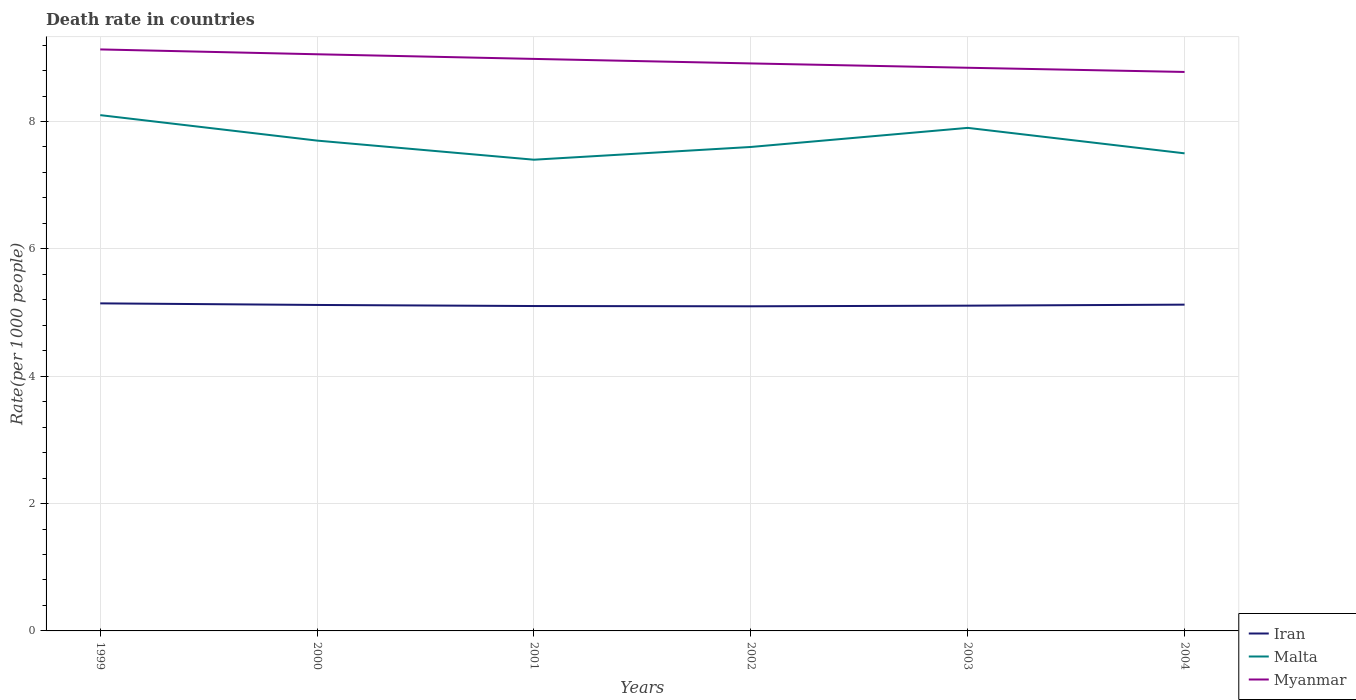How many different coloured lines are there?
Your answer should be compact. 3. Is the number of lines equal to the number of legend labels?
Keep it short and to the point. Yes. Across all years, what is the maximum death rate in Iran?
Your answer should be very brief. 5.1. What is the total death rate in Malta in the graph?
Your answer should be very brief. 0.1. What is the difference between the highest and the second highest death rate in Iran?
Your answer should be compact. 0.05. What is the difference between the highest and the lowest death rate in Iran?
Provide a succinct answer. 3. Is the death rate in Malta strictly greater than the death rate in Myanmar over the years?
Give a very brief answer. Yes. Are the values on the major ticks of Y-axis written in scientific E-notation?
Ensure brevity in your answer.  No. Does the graph contain any zero values?
Make the answer very short. No. What is the title of the graph?
Give a very brief answer. Death rate in countries. Does "Nigeria" appear as one of the legend labels in the graph?
Give a very brief answer. No. What is the label or title of the Y-axis?
Offer a very short reply. Rate(per 1000 people). What is the Rate(per 1000 people) of Iran in 1999?
Your answer should be very brief. 5.14. What is the Rate(per 1000 people) of Malta in 1999?
Provide a short and direct response. 8.1. What is the Rate(per 1000 people) in Myanmar in 1999?
Keep it short and to the point. 9.13. What is the Rate(per 1000 people) of Iran in 2000?
Your answer should be compact. 5.12. What is the Rate(per 1000 people) of Myanmar in 2000?
Ensure brevity in your answer.  9.06. What is the Rate(per 1000 people) in Iran in 2001?
Make the answer very short. 5.1. What is the Rate(per 1000 people) of Myanmar in 2001?
Give a very brief answer. 8.98. What is the Rate(per 1000 people) in Iran in 2002?
Your answer should be very brief. 5.1. What is the Rate(per 1000 people) in Myanmar in 2002?
Provide a succinct answer. 8.91. What is the Rate(per 1000 people) in Iran in 2003?
Your answer should be compact. 5.11. What is the Rate(per 1000 people) of Malta in 2003?
Offer a very short reply. 7.9. What is the Rate(per 1000 people) of Myanmar in 2003?
Your answer should be compact. 8.84. What is the Rate(per 1000 people) in Iran in 2004?
Your response must be concise. 5.12. What is the Rate(per 1000 people) in Malta in 2004?
Your answer should be compact. 7.5. What is the Rate(per 1000 people) in Myanmar in 2004?
Offer a terse response. 8.78. Across all years, what is the maximum Rate(per 1000 people) of Iran?
Offer a terse response. 5.14. Across all years, what is the maximum Rate(per 1000 people) of Malta?
Offer a terse response. 8.1. Across all years, what is the maximum Rate(per 1000 people) of Myanmar?
Ensure brevity in your answer.  9.13. Across all years, what is the minimum Rate(per 1000 people) of Iran?
Keep it short and to the point. 5.1. Across all years, what is the minimum Rate(per 1000 people) in Myanmar?
Keep it short and to the point. 8.78. What is the total Rate(per 1000 people) in Iran in the graph?
Give a very brief answer. 30.7. What is the total Rate(per 1000 people) in Malta in the graph?
Ensure brevity in your answer.  46.2. What is the total Rate(per 1000 people) of Myanmar in the graph?
Provide a succinct answer. 53.7. What is the difference between the Rate(per 1000 people) of Iran in 1999 and that in 2000?
Provide a short and direct response. 0.03. What is the difference between the Rate(per 1000 people) of Malta in 1999 and that in 2000?
Offer a terse response. 0.4. What is the difference between the Rate(per 1000 people) in Myanmar in 1999 and that in 2000?
Provide a succinct answer. 0.08. What is the difference between the Rate(per 1000 people) of Iran in 1999 and that in 2001?
Offer a terse response. 0.04. What is the difference between the Rate(per 1000 people) in Myanmar in 1999 and that in 2001?
Make the answer very short. 0.15. What is the difference between the Rate(per 1000 people) in Iran in 1999 and that in 2002?
Your answer should be very brief. 0.05. What is the difference between the Rate(per 1000 people) in Myanmar in 1999 and that in 2002?
Your answer should be compact. 0.22. What is the difference between the Rate(per 1000 people) in Iran in 1999 and that in 2003?
Offer a very short reply. 0.04. What is the difference between the Rate(per 1000 people) in Myanmar in 1999 and that in 2003?
Offer a terse response. 0.29. What is the difference between the Rate(per 1000 people) of Malta in 1999 and that in 2004?
Make the answer very short. 0.6. What is the difference between the Rate(per 1000 people) in Myanmar in 1999 and that in 2004?
Provide a short and direct response. 0.35. What is the difference between the Rate(per 1000 people) of Iran in 2000 and that in 2001?
Your answer should be compact. 0.02. What is the difference between the Rate(per 1000 people) of Myanmar in 2000 and that in 2001?
Offer a very short reply. 0.07. What is the difference between the Rate(per 1000 people) of Iran in 2000 and that in 2002?
Offer a terse response. 0.02. What is the difference between the Rate(per 1000 people) in Myanmar in 2000 and that in 2002?
Your answer should be compact. 0.14. What is the difference between the Rate(per 1000 people) of Iran in 2000 and that in 2003?
Make the answer very short. 0.01. What is the difference between the Rate(per 1000 people) in Myanmar in 2000 and that in 2003?
Offer a terse response. 0.21. What is the difference between the Rate(per 1000 people) in Iran in 2000 and that in 2004?
Offer a very short reply. -0.01. What is the difference between the Rate(per 1000 people) in Myanmar in 2000 and that in 2004?
Provide a succinct answer. 0.28. What is the difference between the Rate(per 1000 people) in Iran in 2001 and that in 2002?
Ensure brevity in your answer.  0. What is the difference between the Rate(per 1000 people) in Malta in 2001 and that in 2002?
Make the answer very short. -0.2. What is the difference between the Rate(per 1000 people) in Myanmar in 2001 and that in 2002?
Offer a terse response. 0.07. What is the difference between the Rate(per 1000 people) of Iran in 2001 and that in 2003?
Your answer should be compact. -0.01. What is the difference between the Rate(per 1000 people) in Myanmar in 2001 and that in 2003?
Your answer should be very brief. 0.14. What is the difference between the Rate(per 1000 people) in Iran in 2001 and that in 2004?
Offer a very short reply. -0.02. What is the difference between the Rate(per 1000 people) of Myanmar in 2001 and that in 2004?
Ensure brevity in your answer.  0.2. What is the difference between the Rate(per 1000 people) in Iran in 2002 and that in 2003?
Offer a terse response. -0.01. What is the difference between the Rate(per 1000 people) of Malta in 2002 and that in 2003?
Offer a very short reply. -0.3. What is the difference between the Rate(per 1000 people) in Myanmar in 2002 and that in 2003?
Offer a very short reply. 0.07. What is the difference between the Rate(per 1000 people) in Iran in 2002 and that in 2004?
Provide a succinct answer. -0.03. What is the difference between the Rate(per 1000 people) in Myanmar in 2002 and that in 2004?
Offer a terse response. 0.13. What is the difference between the Rate(per 1000 people) of Iran in 2003 and that in 2004?
Your answer should be compact. -0.02. What is the difference between the Rate(per 1000 people) in Malta in 2003 and that in 2004?
Offer a very short reply. 0.4. What is the difference between the Rate(per 1000 people) in Myanmar in 2003 and that in 2004?
Provide a short and direct response. 0.07. What is the difference between the Rate(per 1000 people) in Iran in 1999 and the Rate(per 1000 people) in Malta in 2000?
Offer a very short reply. -2.56. What is the difference between the Rate(per 1000 people) in Iran in 1999 and the Rate(per 1000 people) in Myanmar in 2000?
Provide a short and direct response. -3.91. What is the difference between the Rate(per 1000 people) of Malta in 1999 and the Rate(per 1000 people) of Myanmar in 2000?
Offer a terse response. -0.96. What is the difference between the Rate(per 1000 people) of Iran in 1999 and the Rate(per 1000 people) of Malta in 2001?
Provide a succinct answer. -2.26. What is the difference between the Rate(per 1000 people) in Iran in 1999 and the Rate(per 1000 people) in Myanmar in 2001?
Provide a short and direct response. -3.84. What is the difference between the Rate(per 1000 people) in Malta in 1999 and the Rate(per 1000 people) in Myanmar in 2001?
Keep it short and to the point. -0.88. What is the difference between the Rate(per 1000 people) of Iran in 1999 and the Rate(per 1000 people) of Malta in 2002?
Keep it short and to the point. -2.46. What is the difference between the Rate(per 1000 people) in Iran in 1999 and the Rate(per 1000 people) in Myanmar in 2002?
Your answer should be compact. -3.77. What is the difference between the Rate(per 1000 people) in Malta in 1999 and the Rate(per 1000 people) in Myanmar in 2002?
Offer a terse response. -0.81. What is the difference between the Rate(per 1000 people) in Iran in 1999 and the Rate(per 1000 people) in Malta in 2003?
Your answer should be compact. -2.76. What is the difference between the Rate(per 1000 people) in Iran in 1999 and the Rate(per 1000 people) in Myanmar in 2003?
Offer a very short reply. -3.7. What is the difference between the Rate(per 1000 people) of Malta in 1999 and the Rate(per 1000 people) of Myanmar in 2003?
Ensure brevity in your answer.  -0.74. What is the difference between the Rate(per 1000 people) in Iran in 1999 and the Rate(per 1000 people) in Malta in 2004?
Your response must be concise. -2.36. What is the difference between the Rate(per 1000 people) of Iran in 1999 and the Rate(per 1000 people) of Myanmar in 2004?
Keep it short and to the point. -3.63. What is the difference between the Rate(per 1000 people) in Malta in 1999 and the Rate(per 1000 people) in Myanmar in 2004?
Ensure brevity in your answer.  -0.68. What is the difference between the Rate(per 1000 people) in Iran in 2000 and the Rate(per 1000 people) in Malta in 2001?
Give a very brief answer. -2.28. What is the difference between the Rate(per 1000 people) of Iran in 2000 and the Rate(per 1000 people) of Myanmar in 2001?
Ensure brevity in your answer.  -3.86. What is the difference between the Rate(per 1000 people) in Malta in 2000 and the Rate(per 1000 people) in Myanmar in 2001?
Provide a succinct answer. -1.28. What is the difference between the Rate(per 1000 people) in Iran in 2000 and the Rate(per 1000 people) in Malta in 2002?
Your response must be concise. -2.48. What is the difference between the Rate(per 1000 people) in Iran in 2000 and the Rate(per 1000 people) in Myanmar in 2002?
Give a very brief answer. -3.79. What is the difference between the Rate(per 1000 people) in Malta in 2000 and the Rate(per 1000 people) in Myanmar in 2002?
Give a very brief answer. -1.21. What is the difference between the Rate(per 1000 people) of Iran in 2000 and the Rate(per 1000 people) of Malta in 2003?
Provide a succinct answer. -2.78. What is the difference between the Rate(per 1000 people) of Iran in 2000 and the Rate(per 1000 people) of Myanmar in 2003?
Offer a very short reply. -3.73. What is the difference between the Rate(per 1000 people) of Malta in 2000 and the Rate(per 1000 people) of Myanmar in 2003?
Your answer should be very brief. -1.14. What is the difference between the Rate(per 1000 people) in Iran in 2000 and the Rate(per 1000 people) in Malta in 2004?
Provide a short and direct response. -2.38. What is the difference between the Rate(per 1000 people) in Iran in 2000 and the Rate(per 1000 people) in Myanmar in 2004?
Give a very brief answer. -3.66. What is the difference between the Rate(per 1000 people) in Malta in 2000 and the Rate(per 1000 people) in Myanmar in 2004?
Provide a short and direct response. -1.08. What is the difference between the Rate(per 1000 people) of Iran in 2001 and the Rate(per 1000 people) of Malta in 2002?
Give a very brief answer. -2.5. What is the difference between the Rate(per 1000 people) of Iran in 2001 and the Rate(per 1000 people) of Myanmar in 2002?
Keep it short and to the point. -3.81. What is the difference between the Rate(per 1000 people) in Malta in 2001 and the Rate(per 1000 people) in Myanmar in 2002?
Your response must be concise. -1.51. What is the difference between the Rate(per 1000 people) in Iran in 2001 and the Rate(per 1000 people) in Malta in 2003?
Your response must be concise. -2.8. What is the difference between the Rate(per 1000 people) of Iran in 2001 and the Rate(per 1000 people) of Myanmar in 2003?
Make the answer very short. -3.74. What is the difference between the Rate(per 1000 people) in Malta in 2001 and the Rate(per 1000 people) in Myanmar in 2003?
Make the answer very short. -1.44. What is the difference between the Rate(per 1000 people) of Iran in 2001 and the Rate(per 1000 people) of Malta in 2004?
Your answer should be very brief. -2.4. What is the difference between the Rate(per 1000 people) of Iran in 2001 and the Rate(per 1000 people) of Myanmar in 2004?
Make the answer very short. -3.68. What is the difference between the Rate(per 1000 people) of Malta in 2001 and the Rate(per 1000 people) of Myanmar in 2004?
Your response must be concise. -1.38. What is the difference between the Rate(per 1000 people) in Iran in 2002 and the Rate(per 1000 people) in Malta in 2003?
Your answer should be very brief. -2.8. What is the difference between the Rate(per 1000 people) in Iran in 2002 and the Rate(per 1000 people) in Myanmar in 2003?
Your answer should be very brief. -3.75. What is the difference between the Rate(per 1000 people) in Malta in 2002 and the Rate(per 1000 people) in Myanmar in 2003?
Keep it short and to the point. -1.24. What is the difference between the Rate(per 1000 people) of Iran in 2002 and the Rate(per 1000 people) of Malta in 2004?
Give a very brief answer. -2.4. What is the difference between the Rate(per 1000 people) in Iran in 2002 and the Rate(per 1000 people) in Myanmar in 2004?
Give a very brief answer. -3.68. What is the difference between the Rate(per 1000 people) in Malta in 2002 and the Rate(per 1000 people) in Myanmar in 2004?
Your response must be concise. -1.18. What is the difference between the Rate(per 1000 people) in Iran in 2003 and the Rate(per 1000 people) in Malta in 2004?
Provide a short and direct response. -2.39. What is the difference between the Rate(per 1000 people) in Iran in 2003 and the Rate(per 1000 people) in Myanmar in 2004?
Provide a short and direct response. -3.67. What is the difference between the Rate(per 1000 people) in Malta in 2003 and the Rate(per 1000 people) in Myanmar in 2004?
Offer a very short reply. -0.88. What is the average Rate(per 1000 people) in Iran per year?
Make the answer very short. 5.12. What is the average Rate(per 1000 people) of Malta per year?
Your answer should be compact. 7.7. What is the average Rate(per 1000 people) of Myanmar per year?
Your response must be concise. 8.95. In the year 1999, what is the difference between the Rate(per 1000 people) in Iran and Rate(per 1000 people) in Malta?
Make the answer very short. -2.96. In the year 1999, what is the difference between the Rate(per 1000 people) of Iran and Rate(per 1000 people) of Myanmar?
Offer a terse response. -3.99. In the year 1999, what is the difference between the Rate(per 1000 people) in Malta and Rate(per 1000 people) in Myanmar?
Your response must be concise. -1.03. In the year 2000, what is the difference between the Rate(per 1000 people) in Iran and Rate(per 1000 people) in Malta?
Provide a succinct answer. -2.58. In the year 2000, what is the difference between the Rate(per 1000 people) of Iran and Rate(per 1000 people) of Myanmar?
Provide a succinct answer. -3.94. In the year 2000, what is the difference between the Rate(per 1000 people) in Malta and Rate(per 1000 people) in Myanmar?
Make the answer very short. -1.36. In the year 2001, what is the difference between the Rate(per 1000 people) of Iran and Rate(per 1000 people) of Malta?
Make the answer very short. -2.3. In the year 2001, what is the difference between the Rate(per 1000 people) in Iran and Rate(per 1000 people) in Myanmar?
Provide a short and direct response. -3.88. In the year 2001, what is the difference between the Rate(per 1000 people) in Malta and Rate(per 1000 people) in Myanmar?
Offer a very short reply. -1.58. In the year 2002, what is the difference between the Rate(per 1000 people) of Iran and Rate(per 1000 people) of Malta?
Make the answer very short. -2.5. In the year 2002, what is the difference between the Rate(per 1000 people) of Iran and Rate(per 1000 people) of Myanmar?
Provide a short and direct response. -3.81. In the year 2002, what is the difference between the Rate(per 1000 people) in Malta and Rate(per 1000 people) in Myanmar?
Provide a short and direct response. -1.31. In the year 2003, what is the difference between the Rate(per 1000 people) in Iran and Rate(per 1000 people) in Malta?
Ensure brevity in your answer.  -2.79. In the year 2003, what is the difference between the Rate(per 1000 people) of Iran and Rate(per 1000 people) of Myanmar?
Offer a very short reply. -3.74. In the year 2003, what is the difference between the Rate(per 1000 people) of Malta and Rate(per 1000 people) of Myanmar?
Ensure brevity in your answer.  -0.94. In the year 2004, what is the difference between the Rate(per 1000 people) in Iran and Rate(per 1000 people) in Malta?
Provide a short and direct response. -2.38. In the year 2004, what is the difference between the Rate(per 1000 people) in Iran and Rate(per 1000 people) in Myanmar?
Offer a terse response. -3.65. In the year 2004, what is the difference between the Rate(per 1000 people) in Malta and Rate(per 1000 people) in Myanmar?
Your answer should be very brief. -1.28. What is the ratio of the Rate(per 1000 people) in Malta in 1999 to that in 2000?
Ensure brevity in your answer.  1.05. What is the ratio of the Rate(per 1000 people) in Myanmar in 1999 to that in 2000?
Offer a very short reply. 1.01. What is the ratio of the Rate(per 1000 people) of Iran in 1999 to that in 2001?
Provide a succinct answer. 1.01. What is the ratio of the Rate(per 1000 people) in Malta in 1999 to that in 2001?
Offer a terse response. 1.09. What is the ratio of the Rate(per 1000 people) of Myanmar in 1999 to that in 2001?
Provide a short and direct response. 1.02. What is the ratio of the Rate(per 1000 people) in Malta in 1999 to that in 2002?
Provide a succinct answer. 1.07. What is the ratio of the Rate(per 1000 people) in Myanmar in 1999 to that in 2002?
Your answer should be compact. 1.02. What is the ratio of the Rate(per 1000 people) of Iran in 1999 to that in 2003?
Give a very brief answer. 1.01. What is the ratio of the Rate(per 1000 people) in Malta in 1999 to that in 2003?
Offer a terse response. 1.03. What is the ratio of the Rate(per 1000 people) of Myanmar in 1999 to that in 2003?
Your answer should be very brief. 1.03. What is the ratio of the Rate(per 1000 people) of Malta in 1999 to that in 2004?
Offer a terse response. 1.08. What is the ratio of the Rate(per 1000 people) in Myanmar in 1999 to that in 2004?
Offer a terse response. 1.04. What is the ratio of the Rate(per 1000 people) in Malta in 2000 to that in 2001?
Give a very brief answer. 1.04. What is the ratio of the Rate(per 1000 people) of Iran in 2000 to that in 2002?
Offer a very short reply. 1. What is the ratio of the Rate(per 1000 people) of Malta in 2000 to that in 2002?
Provide a succinct answer. 1.01. What is the ratio of the Rate(per 1000 people) in Myanmar in 2000 to that in 2002?
Provide a succinct answer. 1.02. What is the ratio of the Rate(per 1000 people) of Iran in 2000 to that in 2003?
Your response must be concise. 1. What is the ratio of the Rate(per 1000 people) of Malta in 2000 to that in 2003?
Your answer should be very brief. 0.97. What is the ratio of the Rate(per 1000 people) in Myanmar in 2000 to that in 2003?
Your answer should be compact. 1.02. What is the ratio of the Rate(per 1000 people) in Iran in 2000 to that in 2004?
Your answer should be compact. 1. What is the ratio of the Rate(per 1000 people) of Malta in 2000 to that in 2004?
Ensure brevity in your answer.  1.03. What is the ratio of the Rate(per 1000 people) in Myanmar in 2000 to that in 2004?
Your answer should be compact. 1.03. What is the ratio of the Rate(per 1000 people) of Malta in 2001 to that in 2002?
Your answer should be compact. 0.97. What is the ratio of the Rate(per 1000 people) in Malta in 2001 to that in 2003?
Make the answer very short. 0.94. What is the ratio of the Rate(per 1000 people) in Myanmar in 2001 to that in 2003?
Ensure brevity in your answer.  1.02. What is the ratio of the Rate(per 1000 people) in Iran in 2001 to that in 2004?
Give a very brief answer. 1. What is the ratio of the Rate(per 1000 people) in Malta in 2001 to that in 2004?
Provide a short and direct response. 0.99. What is the ratio of the Rate(per 1000 people) in Myanmar in 2001 to that in 2004?
Give a very brief answer. 1.02. What is the ratio of the Rate(per 1000 people) in Malta in 2002 to that in 2003?
Ensure brevity in your answer.  0.96. What is the ratio of the Rate(per 1000 people) in Myanmar in 2002 to that in 2003?
Provide a succinct answer. 1.01. What is the ratio of the Rate(per 1000 people) in Malta in 2002 to that in 2004?
Ensure brevity in your answer.  1.01. What is the ratio of the Rate(per 1000 people) of Myanmar in 2002 to that in 2004?
Ensure brevity in your answer.  1.02. What is the ratio of the Rate(per 1000 people) in Iran in 2003 to that in 2004?
Keep it short and to the point. 1. What is the ratio of the Rate(per 1000 people) of Malta in 2003 to that in 2004?
Offer a terse response. 1.05. What is the ratio of the Rate(per 1000 people) in Myanmar in 2003 to that in 2004?
Make the answer very short. 1.01. What is the difference between the highest and the second highest Rate(per 1000 people) of Malta?
Provide a succinct answer. 0.2. What is the difference between the highest and the second highest Rate(per 1000 people) in Myanmar?
Your answer should be compact. 0.08. What is the difference between the highest and the lowest Rate(per 1000 people) in Iran?
Offer a terse response. 0.05. What is the difference between the highest and the lowest Rate(per 1000 people) of Myanmar?
Provide a succinct answer. 0.35. 